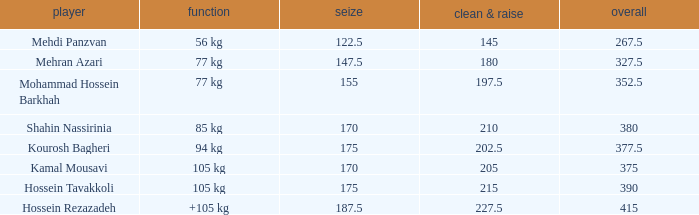Help me parse the entirety of this table. {'header': ['player', 'function', 'seize', 'clean & raise', 'overall'], 'rows': [['Mehdi Panzvan', '56 kg', '122.5', '145', '267.5'], ['Mehran Azari', '77 kg', '147.5', '180', '327.5'], ['Mohammad Hossein Barkhah', '77 kg', '155', '197.5', '352.5'], ['Shahin Nassirinia', '85 kg', '170', '210', '380'], ['Kourosh Bagheri', '94 kg', '175', '202.5', '377.5'], ['Kamal Mousavi', '105 kg', '170', '205', '375'], ['Hossein Tavakkoli', '105 kg', '175', '215', '390'], ['Hossein Rezazadeh', '+105 kg', '187.5', '227.5', '415']]} How many snatches were there with a total of 267.5? 0.0. 